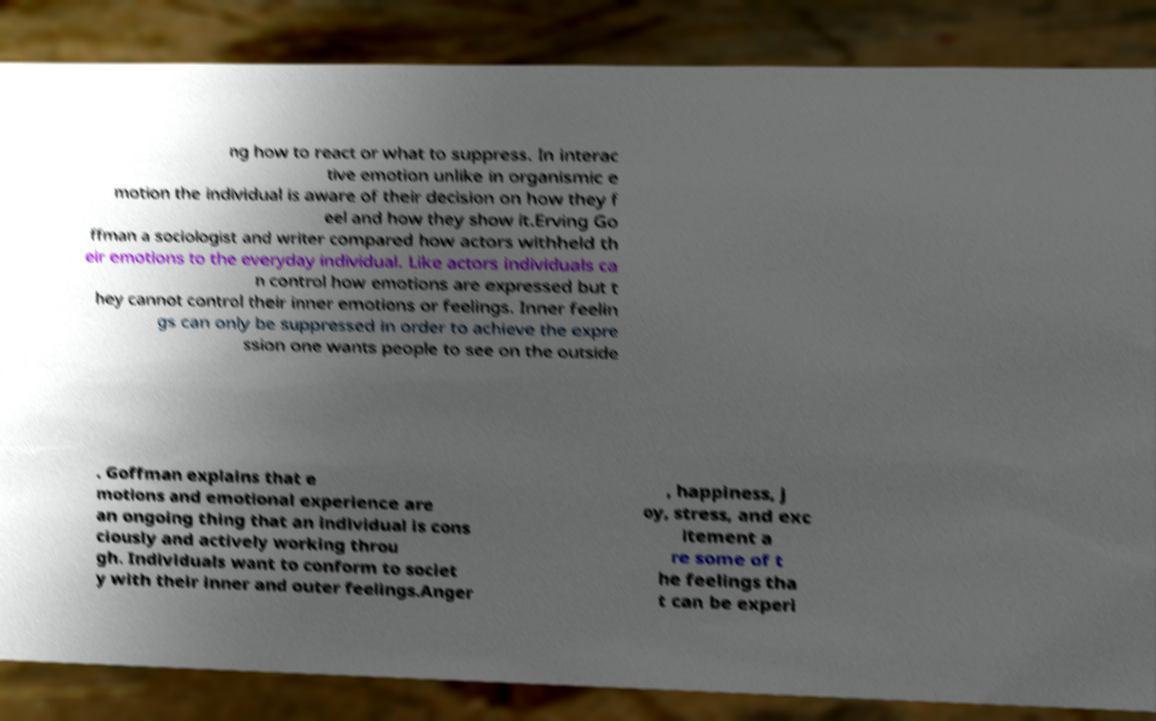What messages or text are displayed in this image? I need them in a readable, typed format. ng how to react or what to suppress. In interac tive emotion unlike in organismic e motion the individual is aware of their decision on how they f eel and how they show it.Erving Go ffman a sociologist and writer compared how actors withheld th eir emotions to the everyday individual. Like actors individuals ca n control how emotions are expressed but t hey cannot control their inner emotions or feelings. Inner feelin gs can only be suppressed in order to achieve the expre ssion one wants people to see on the outside . Goffman explains that e motions and emotional experience are an ongoing thing that an individual is cons ciously and actively working throu gh. Individuals want to conform to societ y with their inner and outer feelings.Anger , happiness, j oy, stress, and exc itement a re some of t he feelings tha t can be experi 